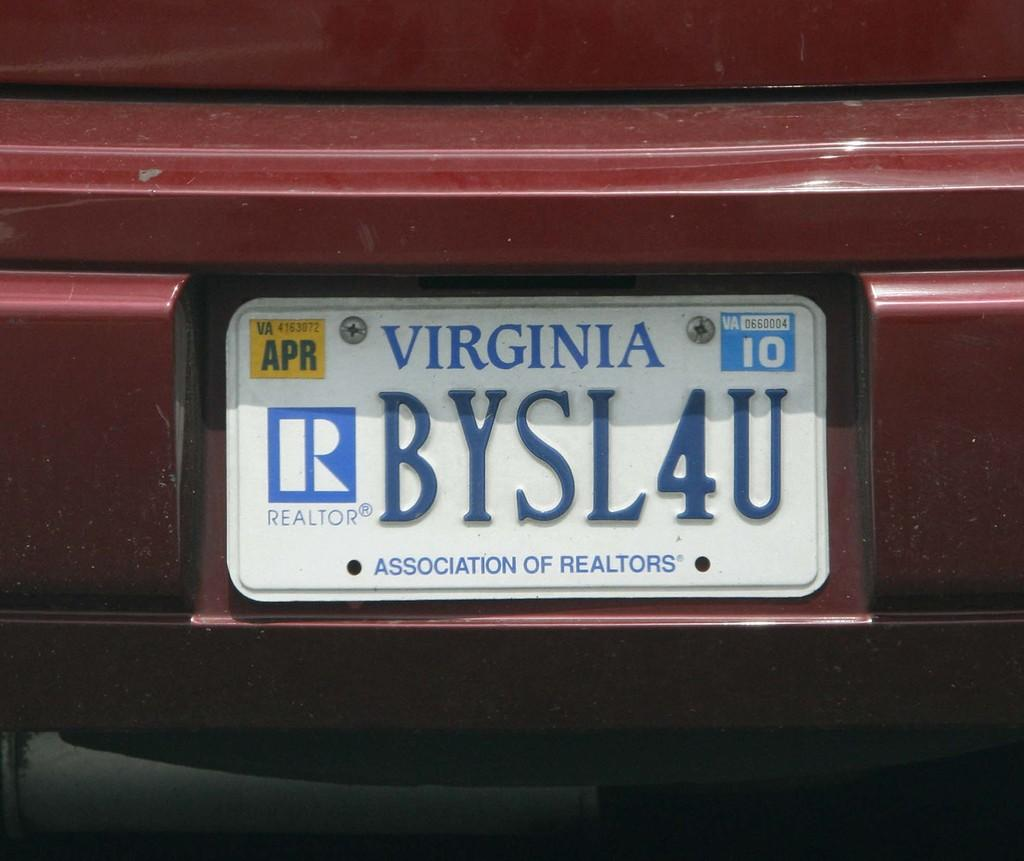What is on the red vehicle in the image? There is a white board on the red vehicle. What can be seen on the white board? There is writing on the white board. Where is the clock located in the image? There is no clock present in the image. What type of market is visible in the image? There is no market present in the image. 